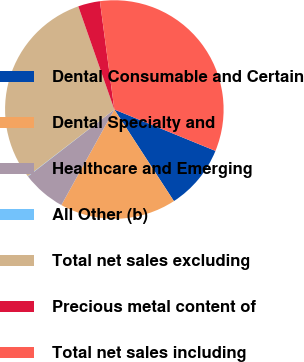Convert chart to OTSL. <chart><loc_0><loc_0><loc_500><loc_500><pie_chart><fcel>Dental Consumable and Certain<fcel>Dental Specialty and<fcel>Healthcare and Emerging<fcel>All Other (b)<fcel>Total net sales excluding<fcel>Precious metal content of<fcel>Total net sales including<nl><fcel>9.64%<fcel>17.23%<fcel>6.44%<fcel>0.05%<fcel>30.1%<fcel>3.24%<fcel>33.29%<nl></chart> 